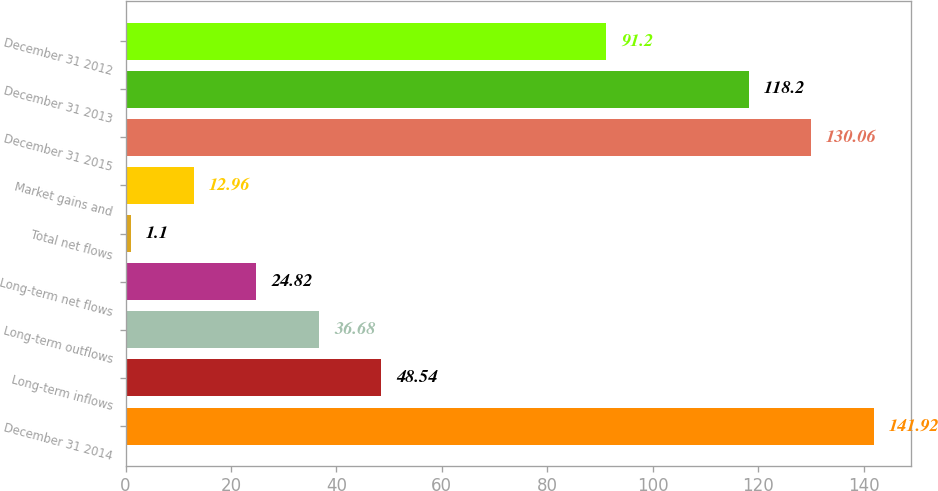Convert chart to OTSL. <chart><loc_0><loc_0><loc_500><loc_500><bar_chart><fcel>December 31 2014<fcel>Long-term inflows<fcel>Long-term outflows<fcel>Long-term net flows<fcel>Total net flows<fcel>Market gains and<fcel>December 31 2015<fcel>December 31 2013<fcel>December 31 2012<nl><fcel>141.92<fcel>48.54<fcel>36.68<fcel>24.82<fcel>1.1<fcel>12.96<fcel>130.06<fcel>118.2<fcel>91.2<nl></chart> 